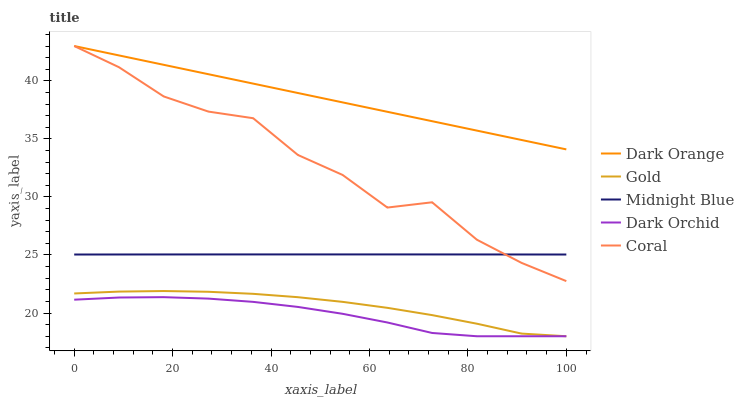Does Dark Orchid have the minimum area under the curve?
Answer yes or no. Yes. Does Dark Orange have the maximum area under the curve?
Answer yes or no. Yes. Does Coral have the minimum area under the curve?
Answer yes or no. No. Does Coral have the maximum area under the curve?
Answer yes or no. No. Is Dark Orange the smoothest?
Answer yes or no. Yes. Is Coral the roughest?
Answer yes or no. Yes. Is Coral the smoothest?
Answer yes or no. No. Is Dark Orange the roughest?
Answer yes or no. No. Does Dark Orchid have the lowest value?
Answer yes or no. Yes. Does Coral have the lowest value?
Answer yes or no. No. Does Coral have the highest value?
Answer yes or no. Yes. Does Midnight Blue have the highest value?
Answer yes or no. No. Is Dark Orchid less than Coral?
Answer yes or no. Yes. Is Midnight Blue greater than Dark Orchid?
Answer yes or no. Yes. Does Dark Orange intersect Coral?
Answer yes or no. Yes. Is Dark Orange less than Coral?
Answer yes or no. No. Is Dark Orange greater than Coral?
Answer yes or no. No. Does Dark Orchid intersect Coral?
Answer yes or no. No. 